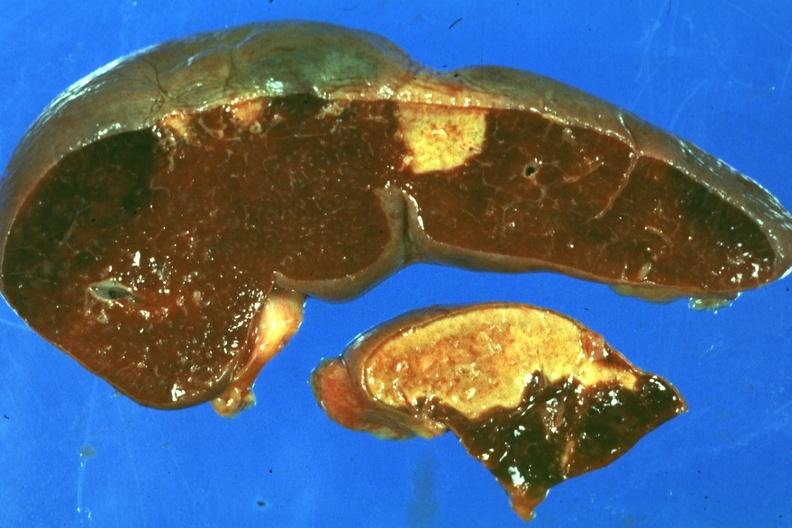where is this part in?
Answer the question using a single word or phrase. Spleen 